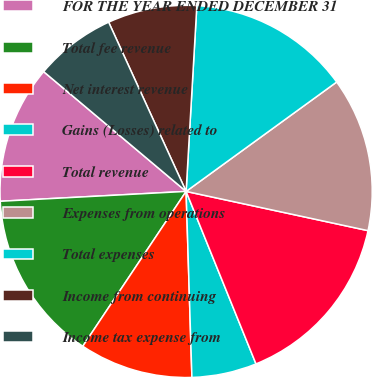Convert chart. <chart><loc_0><loc_0><loc_500><loc_500><pie_chart><fcel>FOR THE YEAR ENDED DECEMBER 31<fcel>Total fee revenue<fcel>Net interest revenue<fcel>Gains (Losses) related to<fcel>Total revenue<fcel>Expenses from operations<fcel>Total expenses<fcel>Income from continuing<fcel>Income tax expense from<nl><fcel>11.97%<fcel>14.79%<fcel>9.86%<fcel>5.63%<fcel>15.49%<fcel>13.38%<fcel>14.08%<fcel>7.75%<fcel>7.04%<nl></chart> 